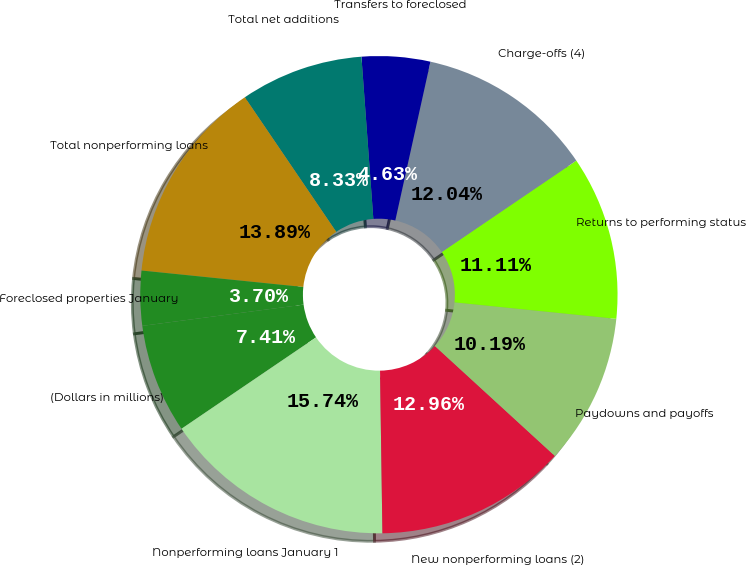Convert chart. <chart><loc_0><loc_0><loc_500><loc_500><pie_chart><fcel>(Dollars in millions)<fcel>Nonperforming loans January 1<fcel>New nonperforming loans (2)<fcel>Paydowns and payoffs<fcel>Returns to performing status<fcel>Charge-offs (4)<fcel>Transfers to foreclosed<fcel>Total net additions<fcel>Total nonperforming loans<fcel>Foreclosed properties January<nl><fcel>7.41%<fcel>15.74%<fcel>12.96%<fcel>10.19%<fcel>11.11%<fcel>12.04%<fcel>4.63%<fcel>8.33%<fcel>13.89%<fcel>3.7%<nl></chart> 